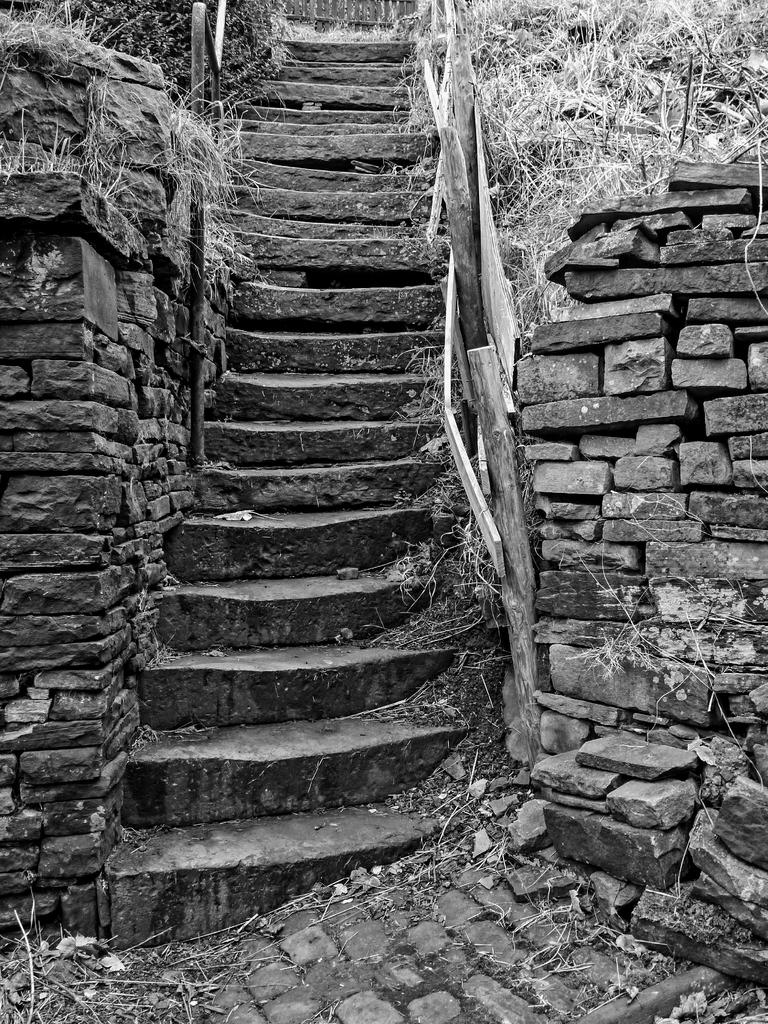What is the color scheme of the image? The image is black and white. What can be seen in the image besides the color scheme? There are stairs in the image. What is the material of the wall beside the stairs? The wall is made of stones. What type of vegetation is visible above the wall? There is dry grass visible above the wall. Where is the dock located in the image? There is no dock present in the image. What type of blade is being used to cut the branch in the image? There is no blade or branch present in the image. 